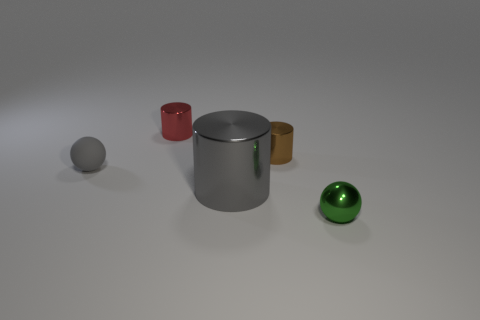There is a sphere that is behind the green ball; does it have the same size as the gray object to the right of the tiny gray ball?
Give a very brief answer. No. Is the large shiny cylinder the same color as the small rubber sphere?
Offer a very short reply. Yes. Is there any other thing that has the same size as the gray metallic cylinder?
Your answer should be very brief. No. There is a cylinder that is the same size as the red object; what material is it?
Your response must be concise. Metal. How big is the object that is both on the right side of the gray shiny cylinder and behind the small green ball?
Ensure brevity in your answer.  Small. What color is the thing that is both behind the tiny rubber thing and on the left side of the brown metallic cylinder?
Give a very brief answer. Red. Is the number of brown shiny cylinders that are behind the tiny red thing less than the number of small gray balls in front of the brown shiny cylinder?
Provide a short and direct response. Yes. What number of tiny shiny objects are the same shape as the tiny gray matte object?
Give a very brief answer. 1. There is a gray cylinder that is the same material as the green object; what is its size?
Give a very brief answer. Large. There is a cylinder that is in front of the brown metallic thing that is behind the big gray cylinder; what is its color?
Your answer should be very brief. Gray. 